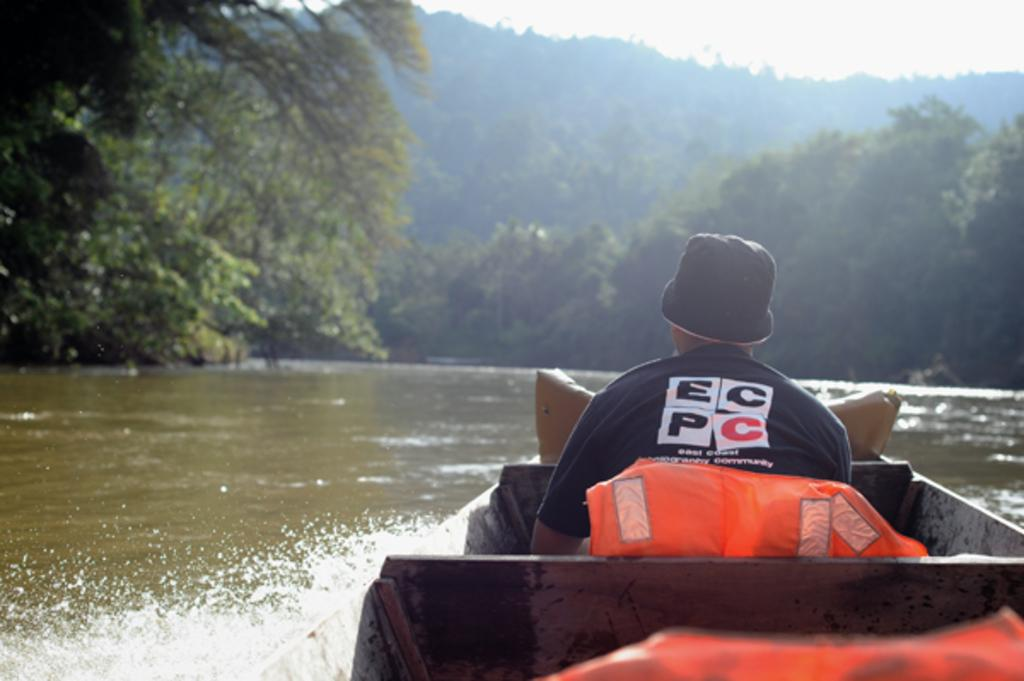Who is present in the image? There is a person in the image. What is the person wearing on their head? The person is wearing a cap. Where is the person sitting in the image? The person is sitting on a boat. What can be seen in the background of the image? There are trees and water visible in the background. What language is the person speaking in the image? There is no indication of the person speaking in the image, so it cannot be determined what language they might be using. 